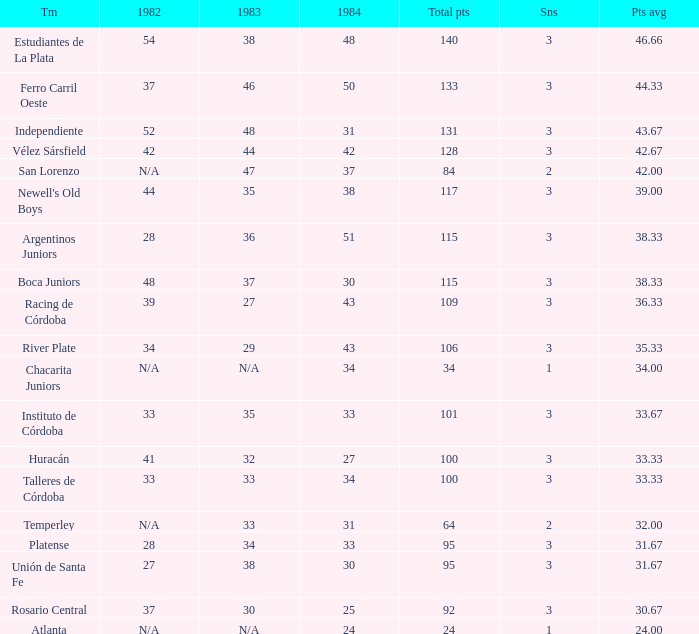What is the points total for the team with points average more than 34, 1984 score more than 37 and N/A in 1982? 0.0. 